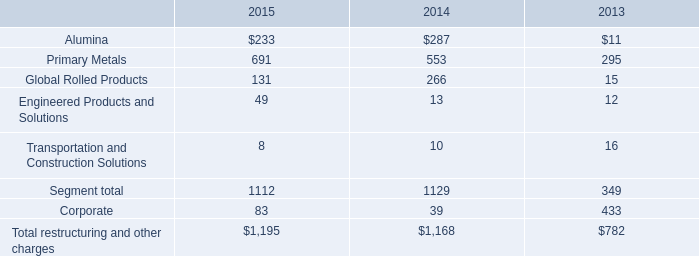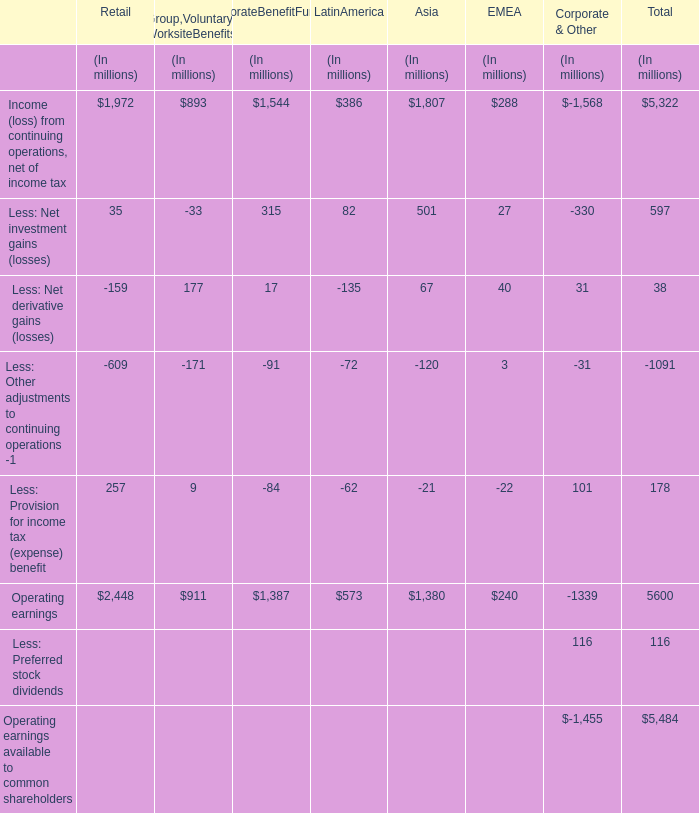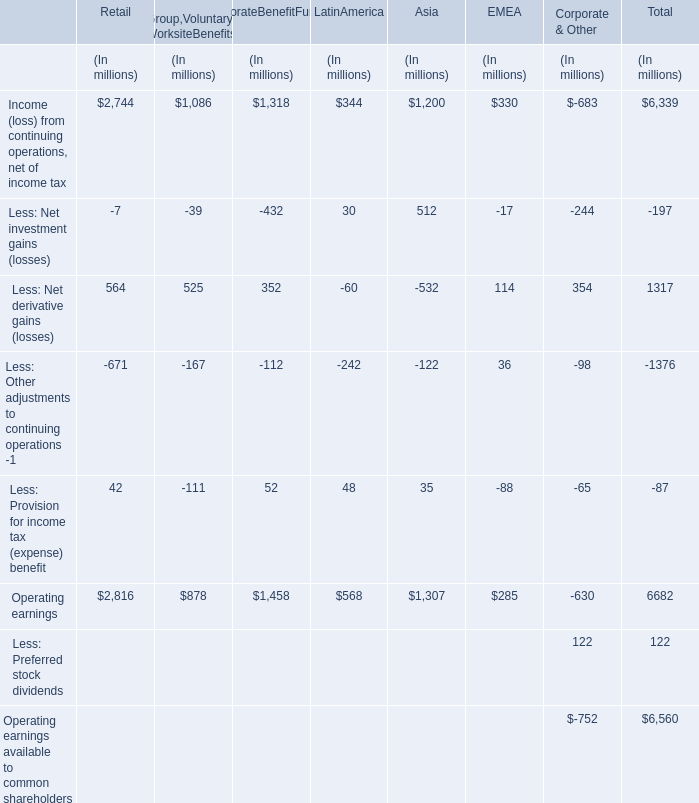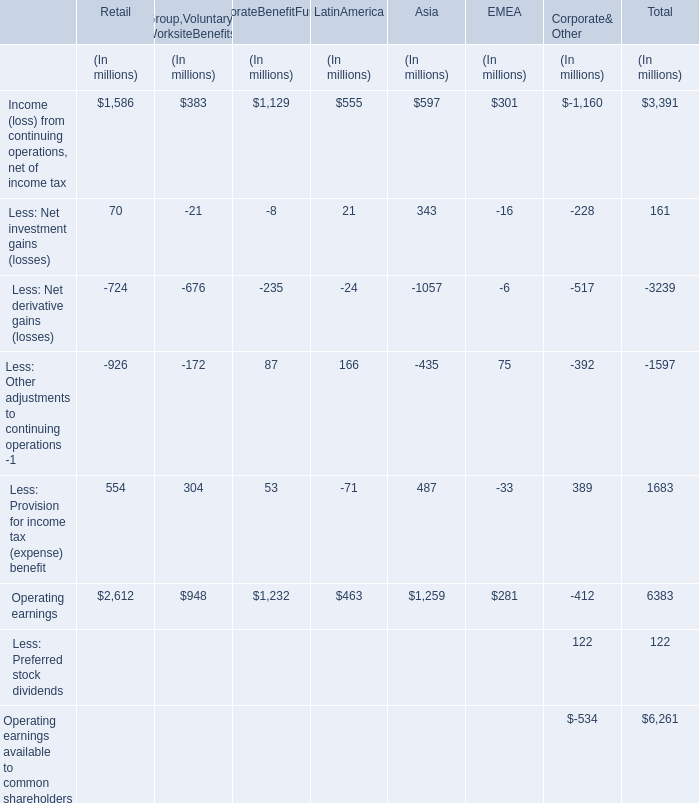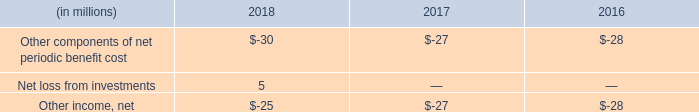How much is the greatest Operating earnings in all sections except section Total more than the Operating earnings in section Corporate Benefit Funding? (in million) 
Computations: (2816 - 1458)
Answer: 1358.0. 